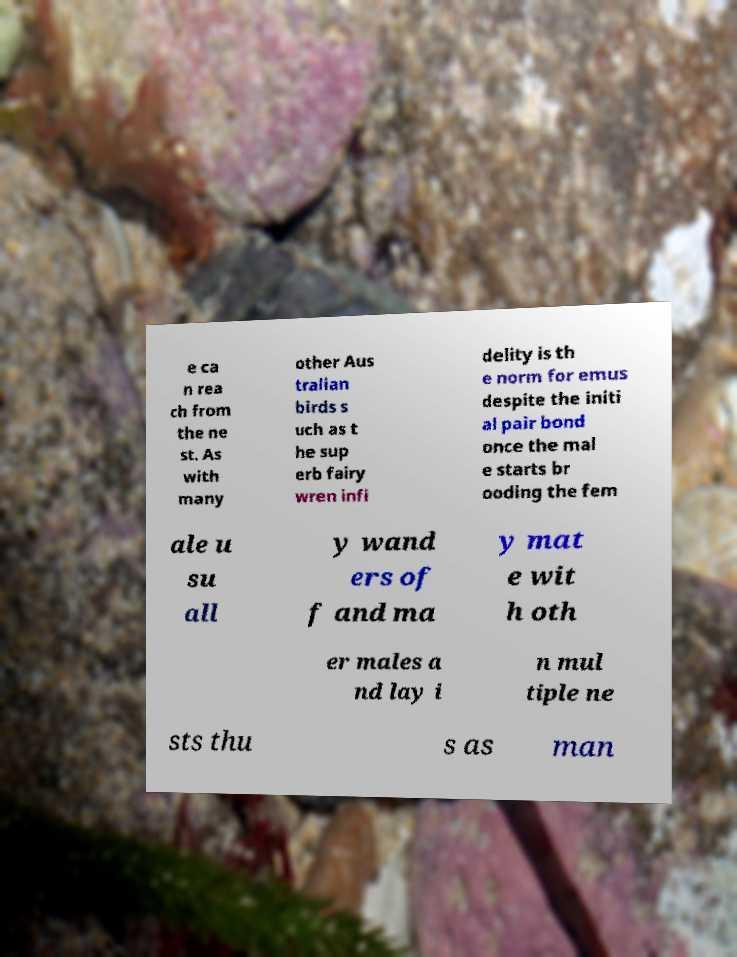Can you accurately transcribe the text from the provided image for me? e ca n rea ch from the ne st. As with many other Aus tralian birds s uch as t he sup erb fairy wren infi delity is th e norm for emus despite the initi al pair bond once the mal e starts br ooding the fem ale u su all y wand ers of f and ma y mat e wit h oth er males a nd lay i n mul tiple ne sts thu s as man 